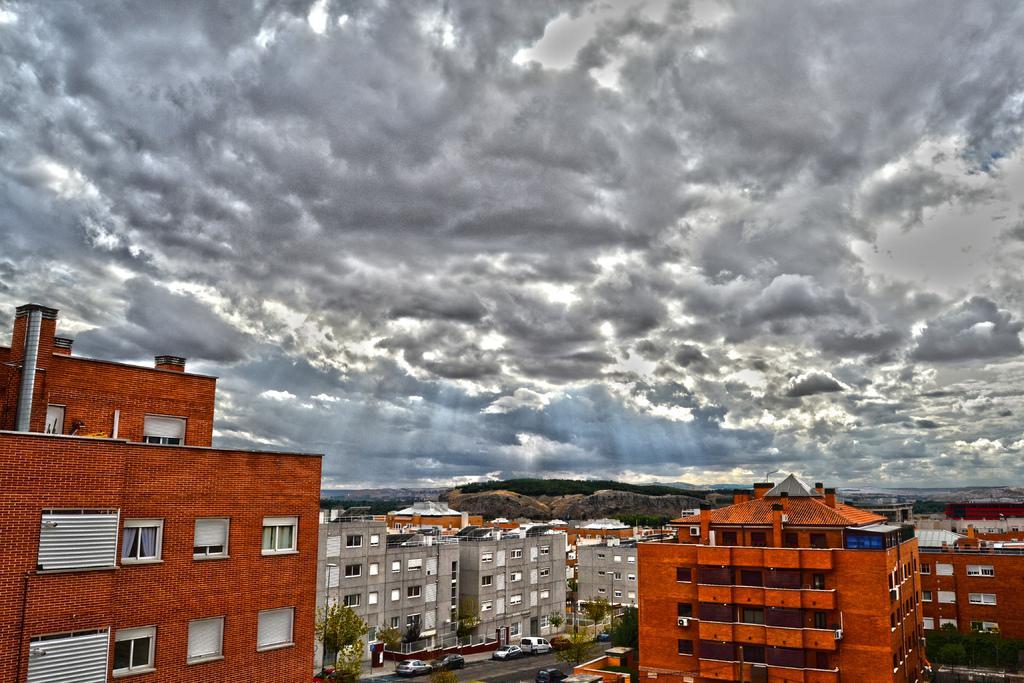In one or two sentences, can you explain what this image depicts? On the left side it is a building in orange color. In the middle few cars are parked on this road. At the top it's a cloudy sky. 